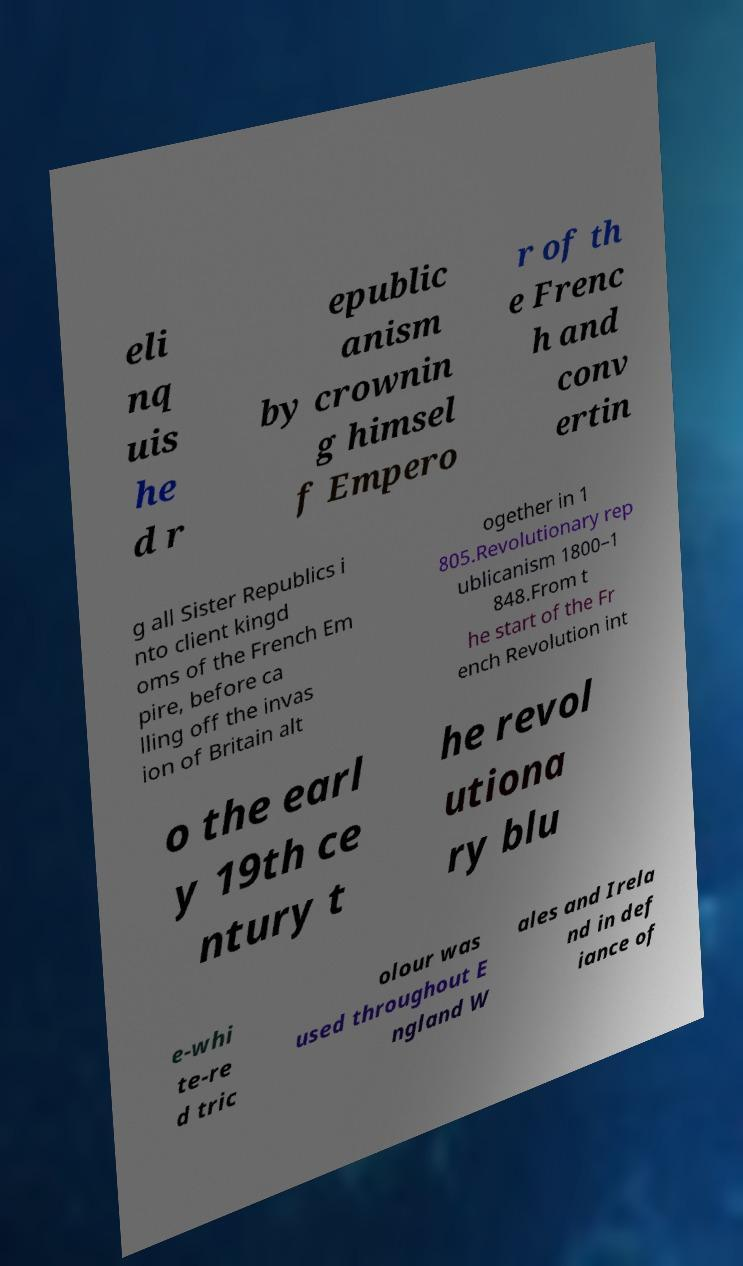What messages or text are displayed in this image? I need them in a readable, typed format. eli nq uis he d r epublic anism by crownin g himsel f Empero r of th e Frenc h and conv ertin g all Sister Republics i nto client kingd oms of the French Em pire, before ca lling off the invas ion of Britain alt ogether in 1 805.Revolutionary rep ublicanism 1800–1 848.From t he start of the Fr ench Revolution int o the earl y 19th ce ntury t he revol utiona ry blu e-whi te-re d tric olour was used throughout E ngland W ales and Irela nd in def iance of 